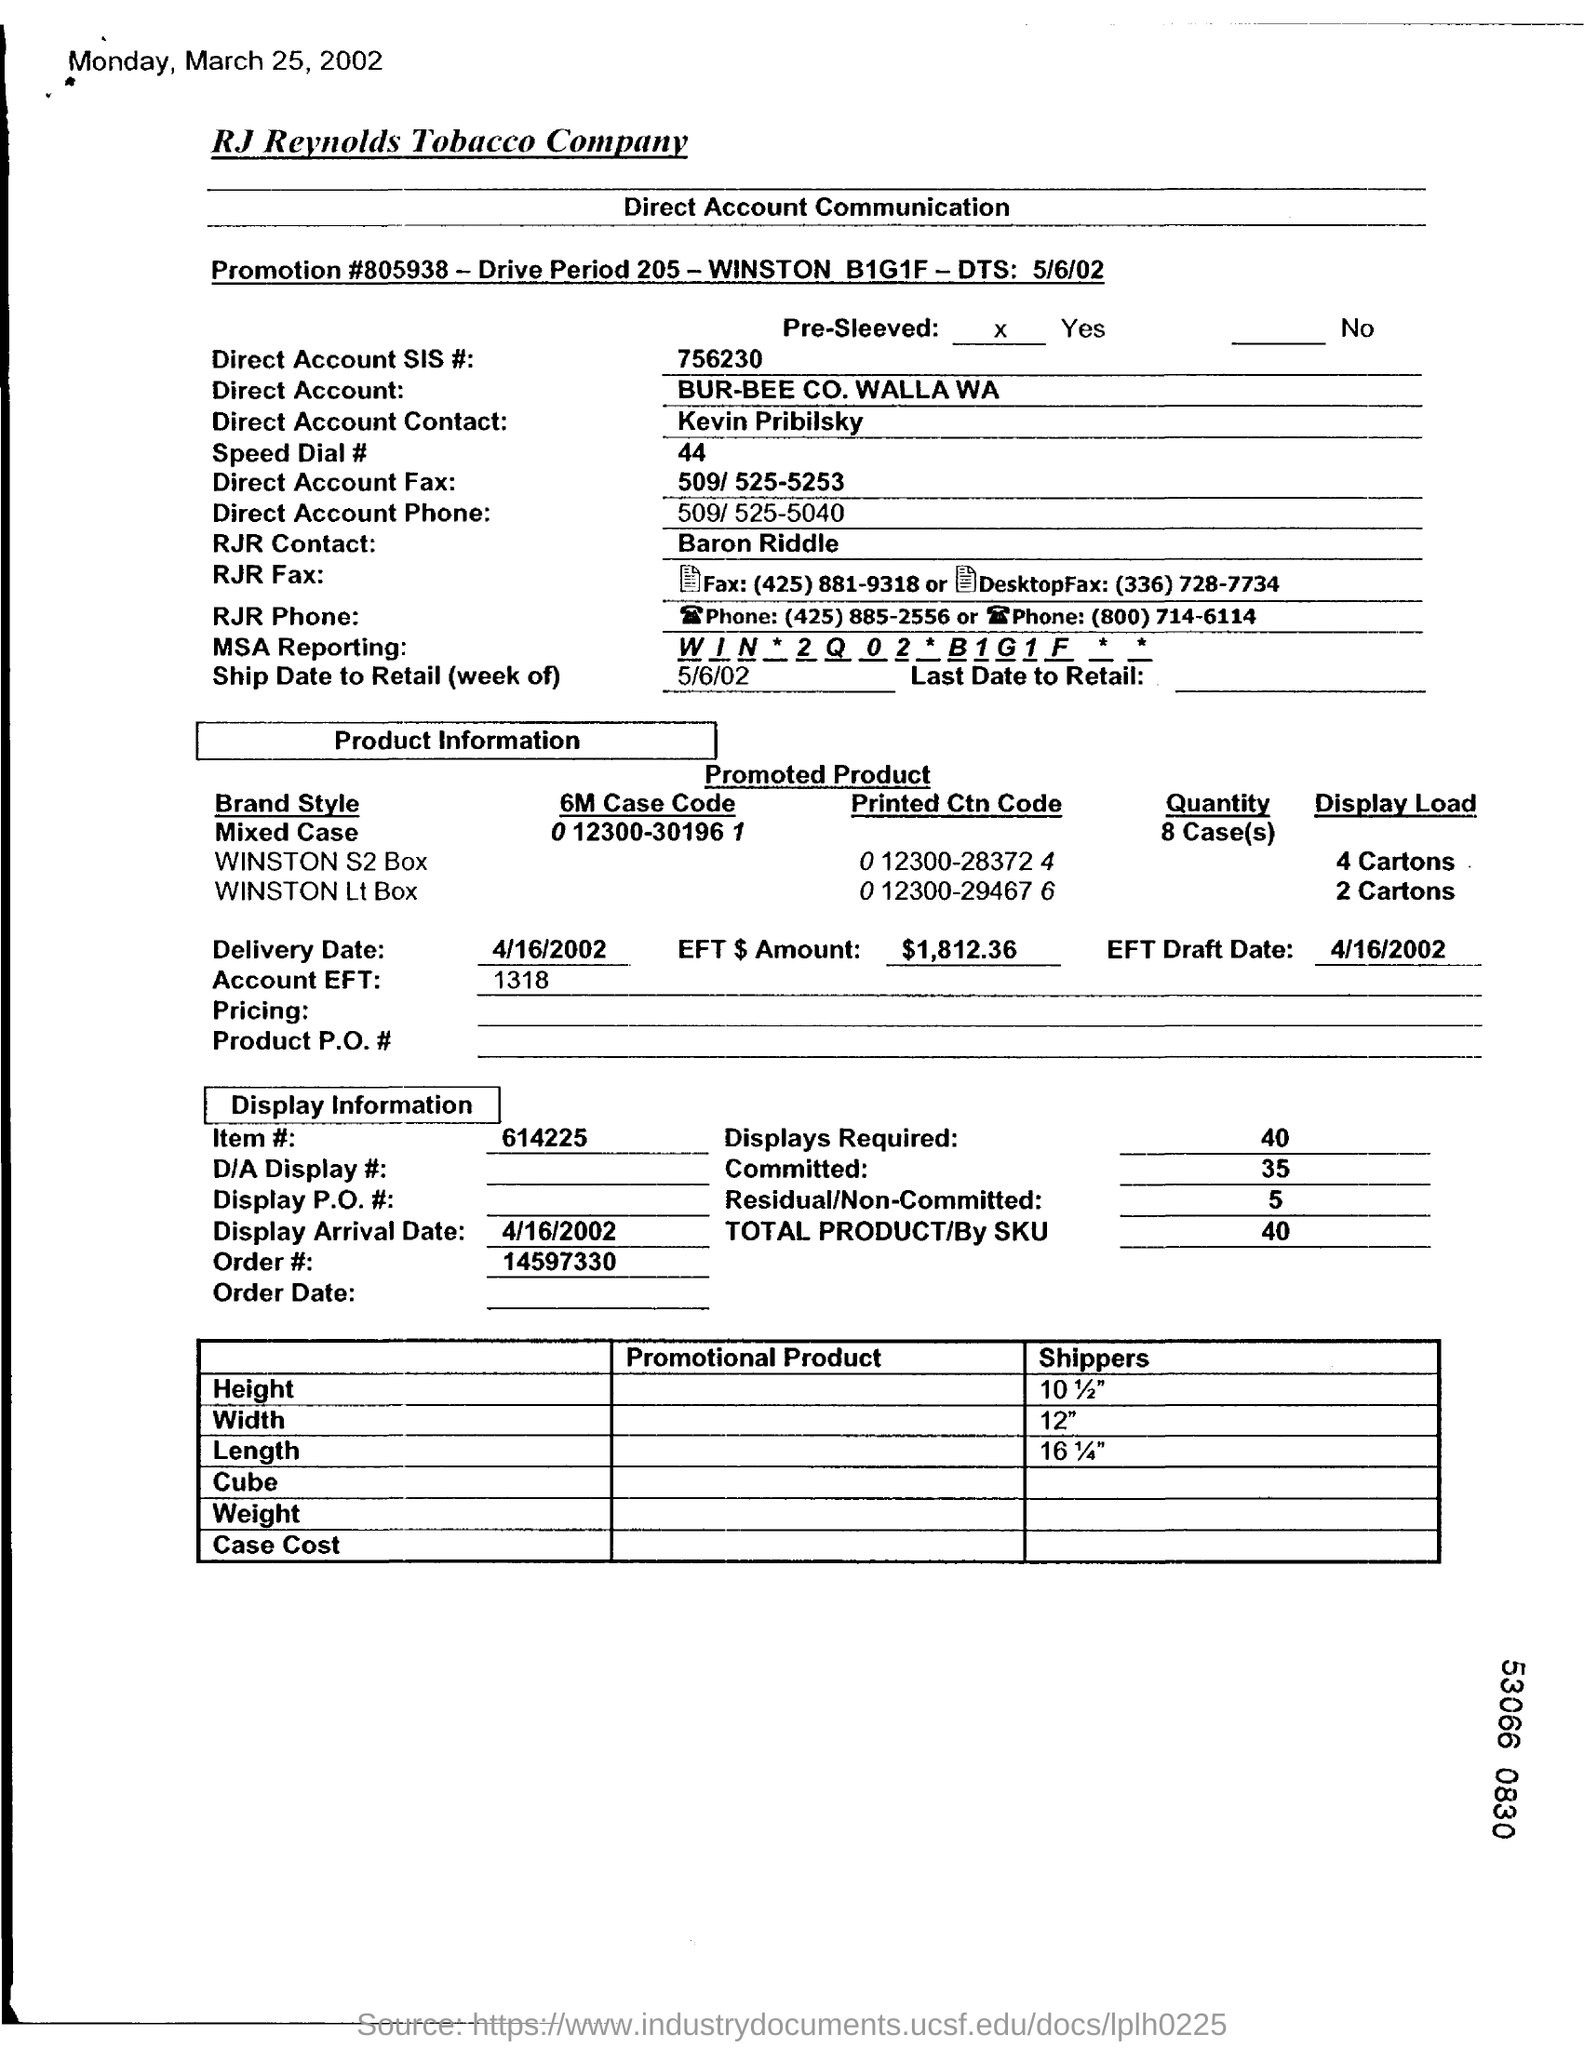Who is the RJR contact?
Keep it short and to the point. Baron Riddle. When is the Display Arrival Date?
Offer a terse response. 4/16/2002. 